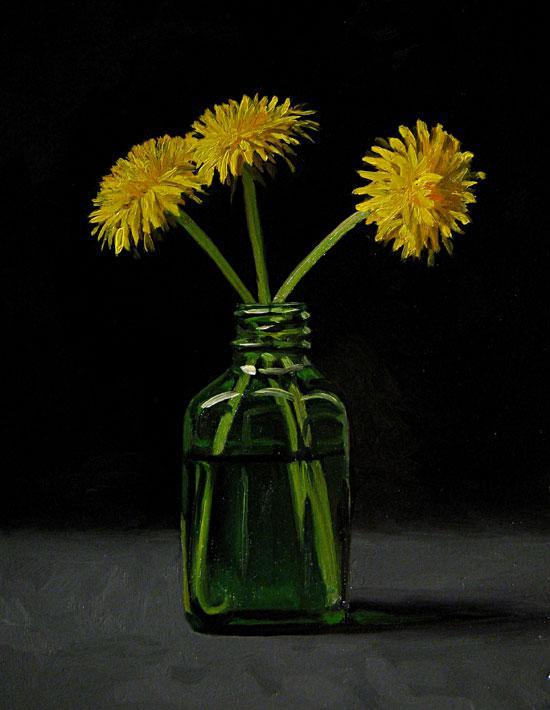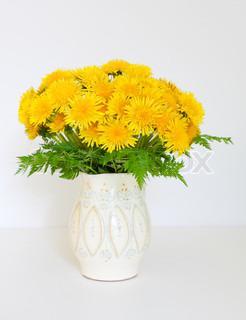The first image is the image on the left, the second image is the image on the right. For the images displayed, is the sentence "The white vase is filled with yellow flowers." factually correct? Answer yes or no. Yes. 